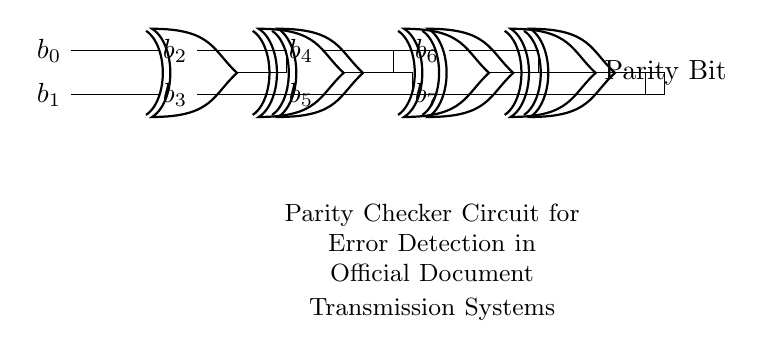What type of circuit is displayed? The circuit is a parity checker, which is designed to detect errors in data transmission by generating a parity bit based on the inputs.
Answer: Parity checker How many XOR gates are used in this circuit? There are seven XOR gates in total, which include four original gates and three additional gates formed by interconnections.
Answer: Seven What signals are used as inputs to the circuit? The inputs are b0, b1, b2, b3, b4, b5, b6, and b7, which likely represent bits of data being transmitted that need to be checked for parity.
Answer: b0, b1, b2, b3, b4, b5, b6, b7 What is the output of the circuit labeled as? The output of the circuit is labeled as "Parity Bit," indicating it provides a single bit used to determine the even or odd parity of the input bits.
Answer: Parity Bit Why is the XOR gate used in this circuit? XOR gates are used because they output true (or high) only when an odd number of their inputs are true, making them ideal for parity checking where we need to determine if the count of '1's is even or odd.
Answer: To check parity How does the number of ones in the input relate to the Parity Bit output? The Parity Bit output will be '1' if the count of input '1's is odd, indicating that an error may have occurred, while it will be '0' if the count is even, showing no error detected.
Answer: Odd counts produce 1, even counts produce 0 